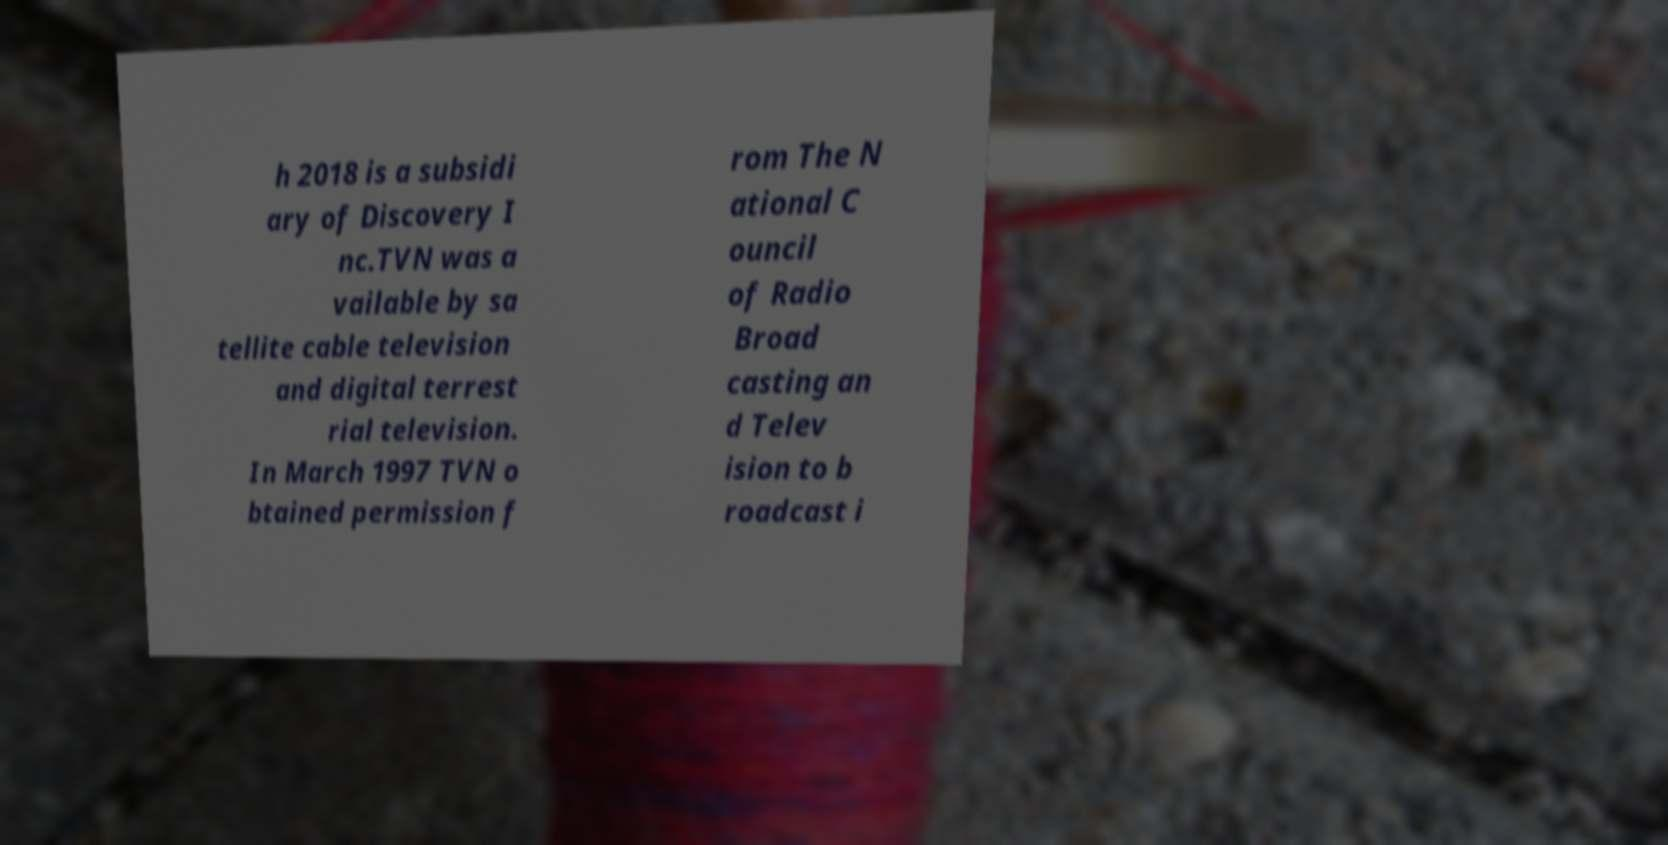Can you read and provide the text displayed in the image?This photo seems to have some interesting text. Can you extract and type it out for me? h 2018 is a subsidi ary of Discovery I nc.TVN was a vailable by sa tellite cable television and digital terrest rial television. In March 1997 TVN o btained permission f rom The N ational C ouncil of Radio Broad casting an d Telev ision to b roadcast i 